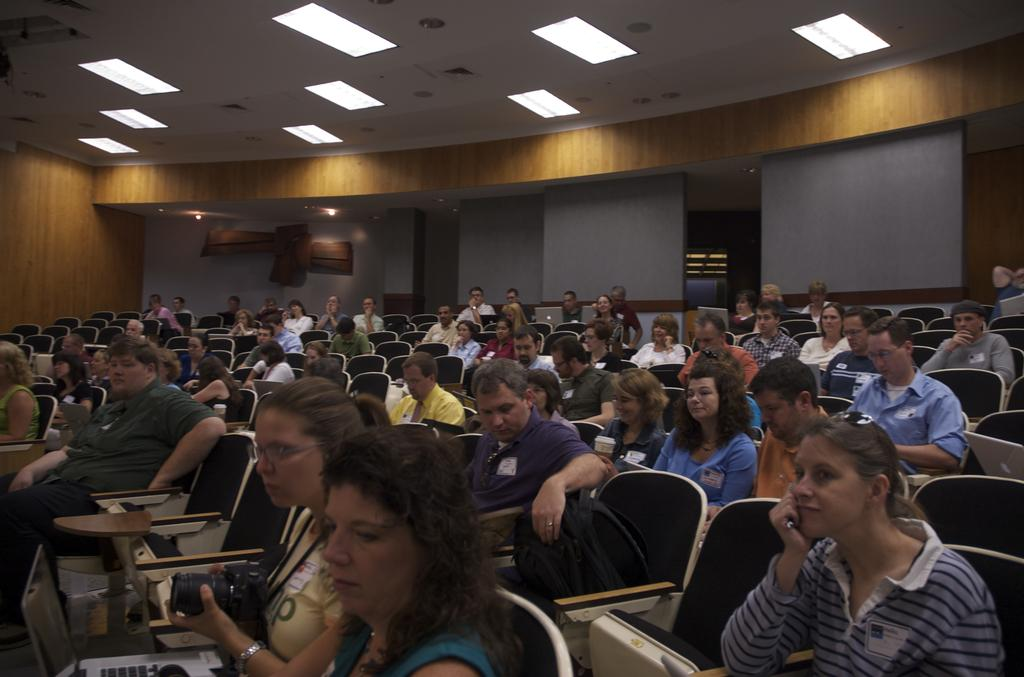What are the people in the image doing? The people in the image are sitting on chairs. What can be seen in the background of the image? There is a wall visible in the background of the image. What is at the top of the image? There is a roof at the top of the image, and lights are also present. What type of sack is being used as a tablecloth in the image? There is no sack present in the image, nor is there a tablecloth. 